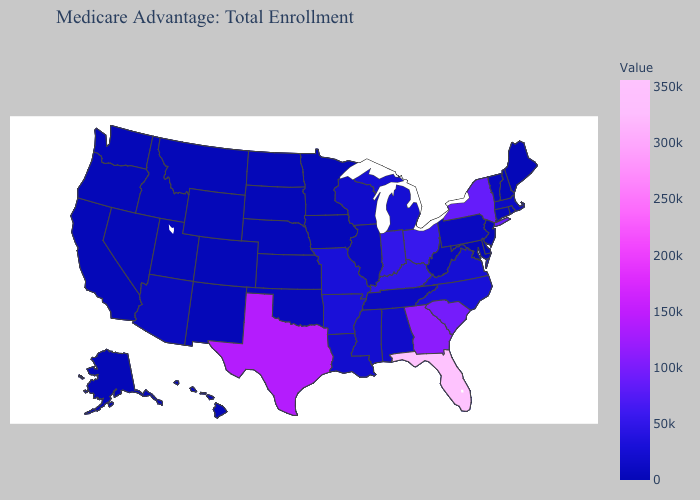Which states have the highest value in the USA?
Be succinct. Florida. Does Maryland have the lowest value in the South?
Concise answer only. Yes. Which states have the highest value in the USA?
Write a very short answer. Florida. Does Massachusetts have the lowest value in the USA?
Give a very brief answer. No. Which states hav the highest value in the West?
Quick response, please. Arizona. Does Missouri have the lowest value in the MidWest?
Write a very short answer. No. Which states hav the highest value in the South?
Concise answer only. Florida. 